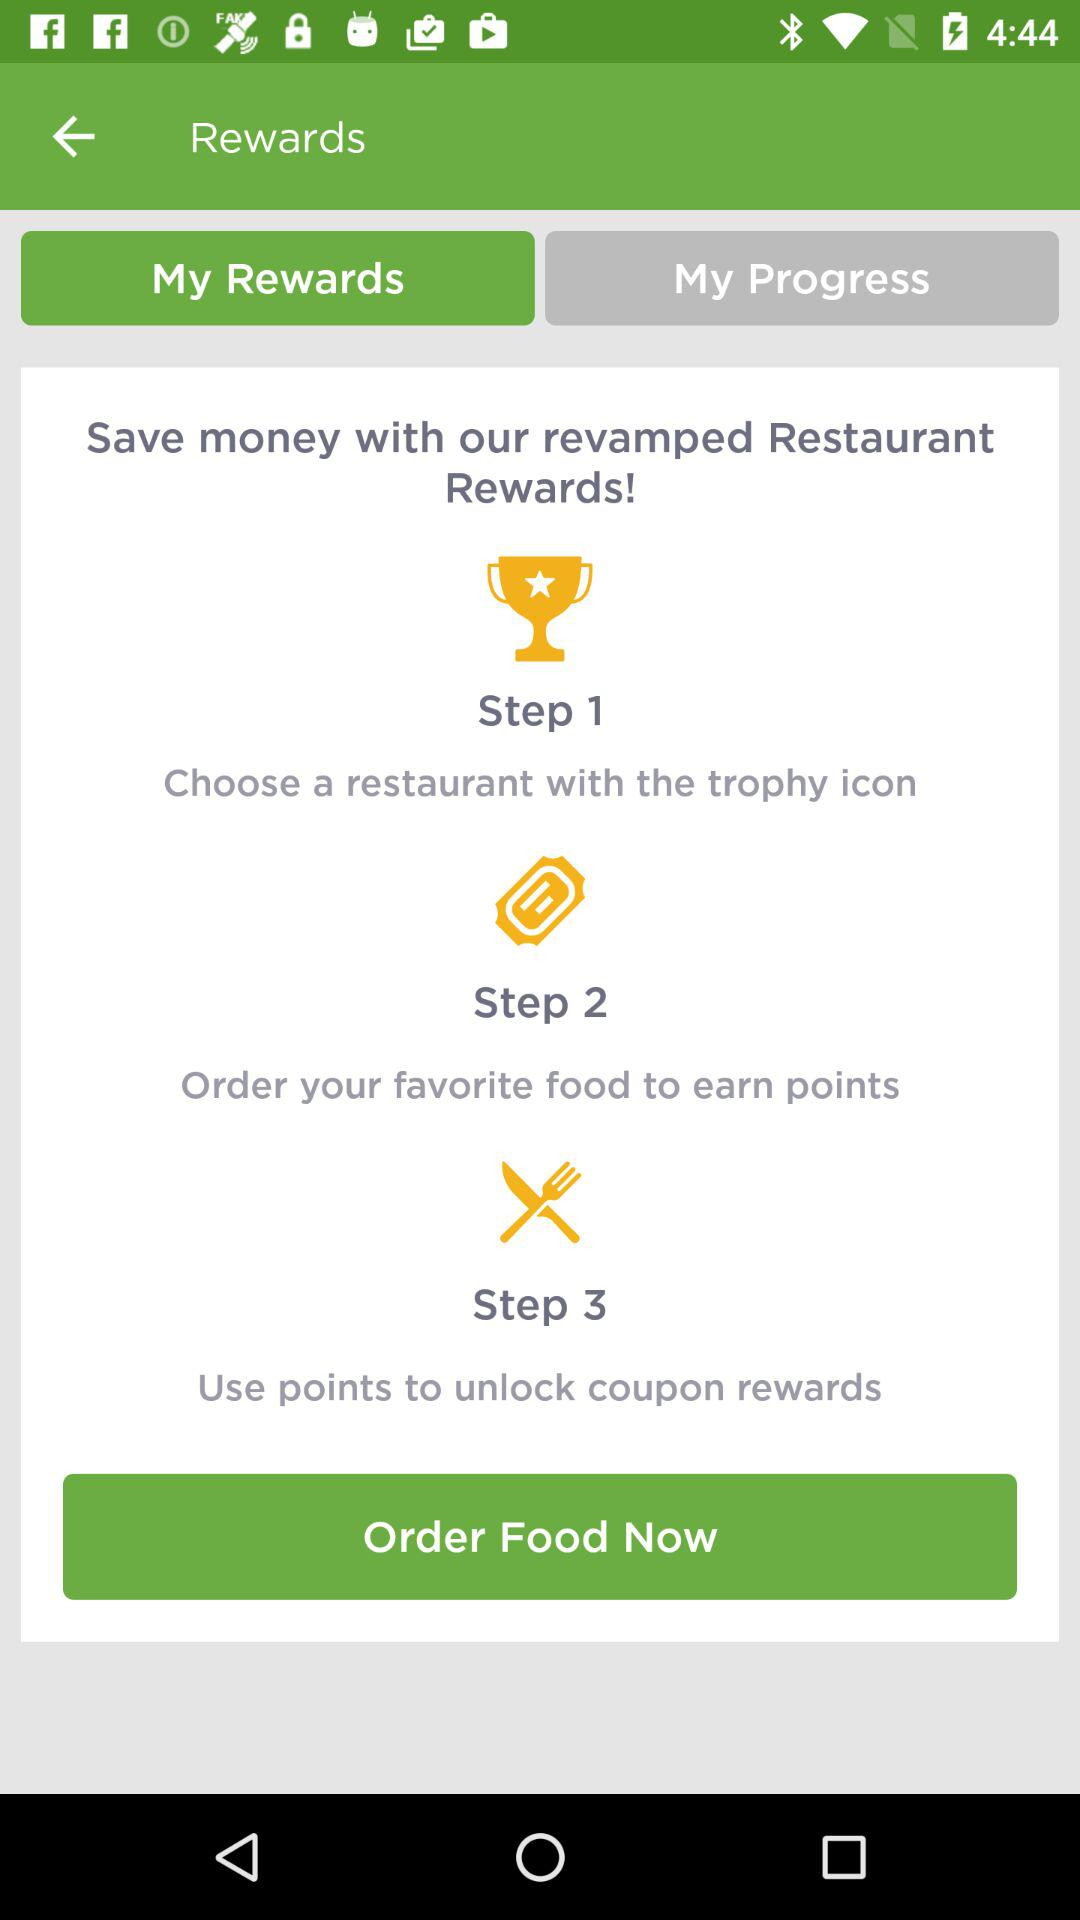How many steps are there in the rewards program?
Answer the question using a single word or phrase. 3 